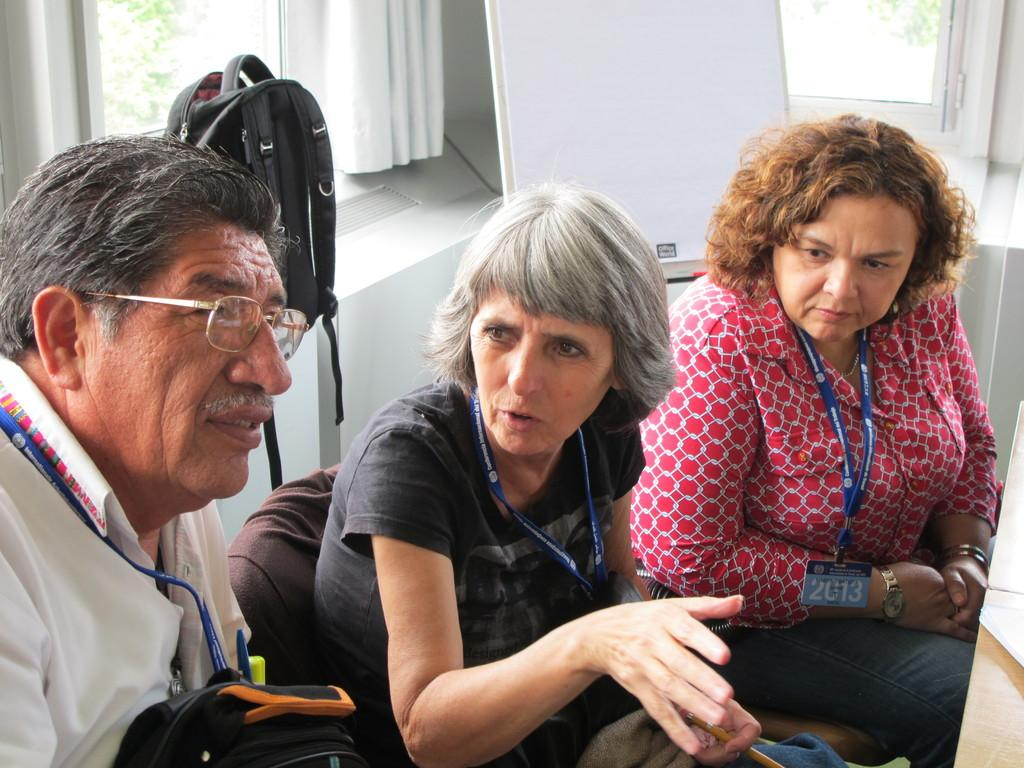What objects can be seen in the image? There are bags in the image. How many people are present in the image? There are three people in the image. What are the people wearing that might identify them? The people are wearing ID cards. What are the people doing in the image? The people are sitting on chairs. What can be seen in the background of the image? There is a board, a curtain, windows, and leaves visible in the background of the image. What type of chin is visible on the person sitting on the left chair? There is no chin visible on the person sitting on the left chair, as the image does not show the people's faces. What is the relationship between the people in the image? The provided facts do not mention any relationships between the people in the image. 